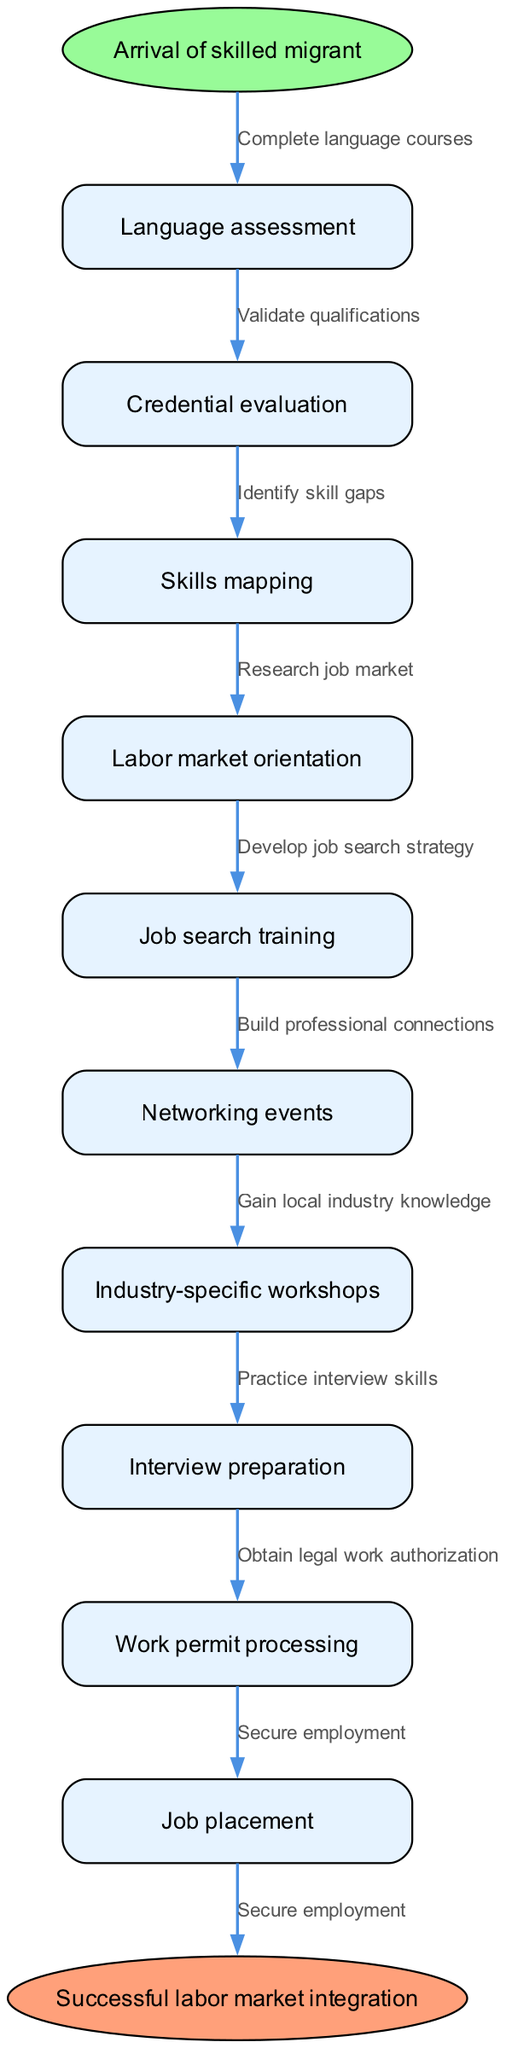What is the starting point of the diagram? The starting point is labeled as "Arrival of skilled migrant," which is located at the top of the diagram.
Answer: Arrival of skilled migrant How many nodes are present in the diagram? The diagram contains ten nodes, which are connected in a sequence from the start point to the endpoint.
Answer: 10 What is the last node before reaching the successful labor market integration? The last node before reaching the endpoint is "Job placement," which directly connects to the endpoint.
Answer: Job placement What is the edge that connects "Skills mapping" to the next node? The edge connecting "Skills mapping" to the next node is labeled as "Identify skill gaps," which indicates the subsequent action taken after skills mapping.
Answer: Identify skill gaps Which node follows "Labor market orientation" in the workflow? The node that follows "Labor market orientation" is "Job search training," showing the progression of the process.
Answer: Job search training What is the final result indicated in the diagram? The final result indicated in the diagram is "Successful labor market integration," which represents the ultimate goal of the pathway.
Answer: Successful labor market integration What edge connects "Interview preparation" to its next node? The edge that connects "Interview preparation" to the next node is labeled as "Practice interview skills," showing what is done after preparation.
Answer: Practice interview skills Which two nodes are connected by the edge "Complete language courses"? The edge "Complete language courses" connects the starting point "Arrival of skilled migrant" to the first node "Language assessment," indicating an action to be taken.
Answer: Arrival of skilled migrant and Language assessment What action is indicated by the edge between "Networking events" and the subsequent node? The action indicated by the edge is "Build professional connections," which describes what participants aim for after attending the networking events.
Answer: Build professional connections 